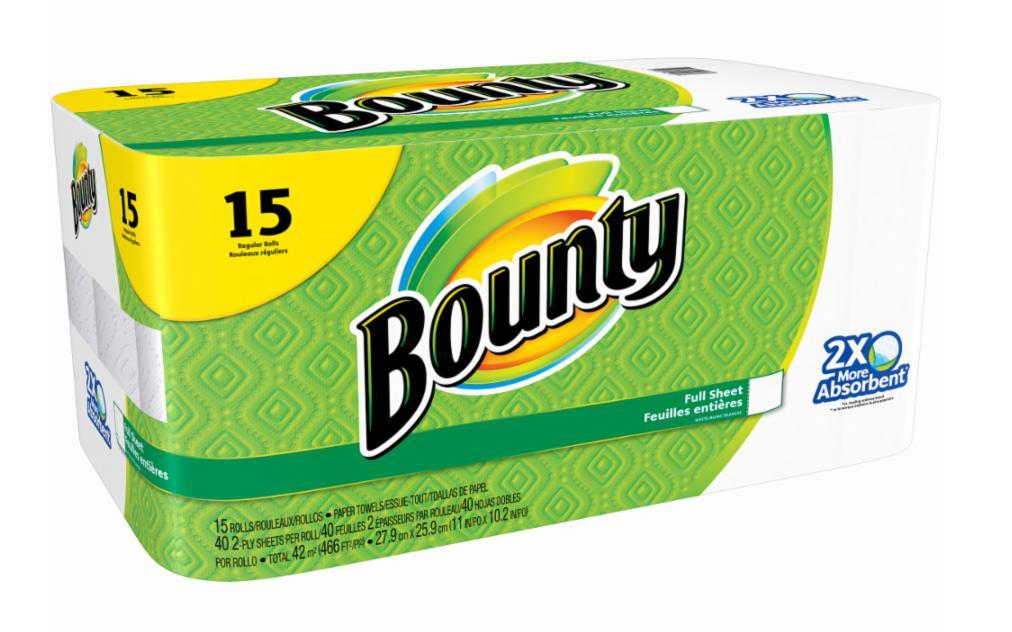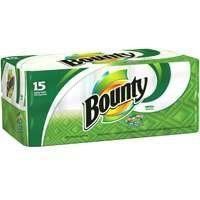The first image is the image on the left, the second image is the image on the right. Examine the images to the left and right. Is the description "The left image shows one multi-roll package of towels with a yellow quarter circle in the upper left corner, and the package on the right features the same basic color scheme as the pack on the left." accurate? Answer yes or no. Yes. 